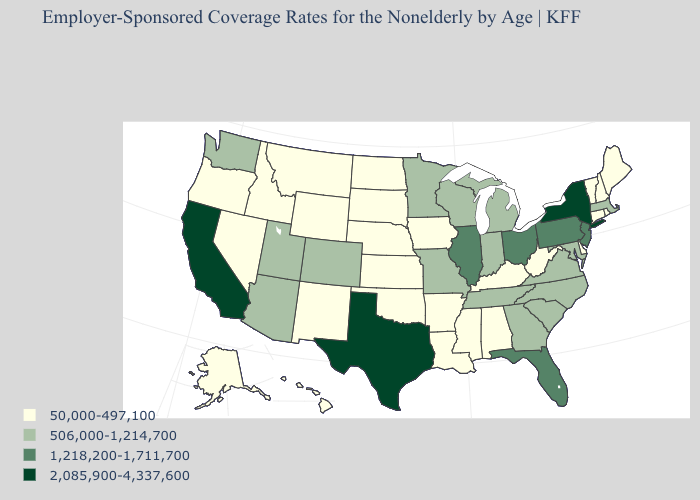What is the value of Nevada?
Concise answer only. 50,000-497,100. Name the states that have a value in the range 1,218,200-1,711,700?
Be succinct. Florida, Illinois, New Jersey, Ohio, Pennsylvania. Does Montana have the lowest value in the USA?
Short answer required. Yes. Does the map have missing data?
Answer briefly. No. Name the states that have a value in the range 1,218,200-1,711,700?
Quick response, please. Florida, Illinois, New Jersey, Ohio, Pennsylvania. Name the states that have a value in the range 2,085,900-4,337,600?
Give a very brief answer. California, New York, Texas. What is the lowest value in the USA?
Give a very brief answer. 50,000-497,100. Which states have the lowest value in the MidWest?
Give a very brief answer. Iowa, Kansas, Nebraska, North Dakota, South Dakota. Does Oklahoma have the lowest value in the South?
Answer briefly. Yes. Does New York have the highest value in the USA?
Quick response, please. Yes. Does the first symbol in the legend represent the smallest category?
Quick response, please. Yes. What is the value of Nebraska?
Write a very short answer. 50,000-497,100. Name the states that have a value in the range 1,218,200-1,711,700?
Quick response, please. Florida, Illinois, New Jersey, Ohio, Pennsylvania. Does Arizona have the lowest value in the West?
Write a very short answer. No. Name the states that have a value in the range 2,085,900-4,337,600?
Answer briefly. California, New York, Texas. 